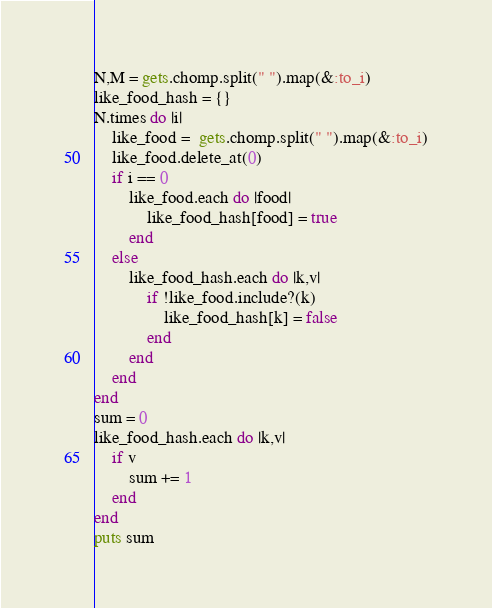Convert code to text. <code><loc_0><loc_0><loc_500><loc_500><_Ruby_>N,M = gets.chomp.split(" ").map(&:to_i)
like_food_hash = {}
N.times do |i|
    like_food =  gets.chomp.split(" ").map(&:to_i)
    like_food.delete_at(0)
    if i == 0
        like_food.each do |food|
            like_food_hash[food] = true
        end
    else
        like_food_hash.each do |k,v|
            if !like_food.include?(k) 
                like_food_hash[k] = false
            end
        end
    end
end
sum = 0
like_food_hash.each do |k,v|
    if v 
        sum += 1
    end
end
puts sum
</code> 